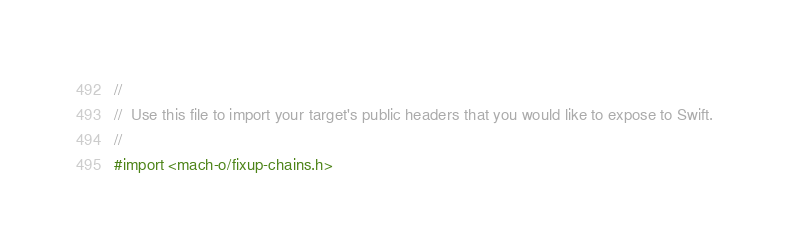Convert code to text. <code><loc_0><loc_0><loc_500><loc_500><_C_>//
//  Use this file to import your target's public headers that you would like to expose to Swift.
//
#import <mach-o/fixup-chains.h>
</code> 